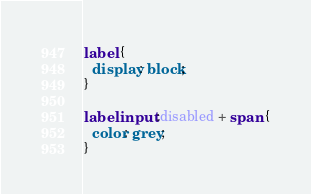<code> <loc_0><loc_0><loc_500><loc_500><_CSS_>label {
  display: block;
}

label input:disabled + span {
  color: grey;
}
</code> 